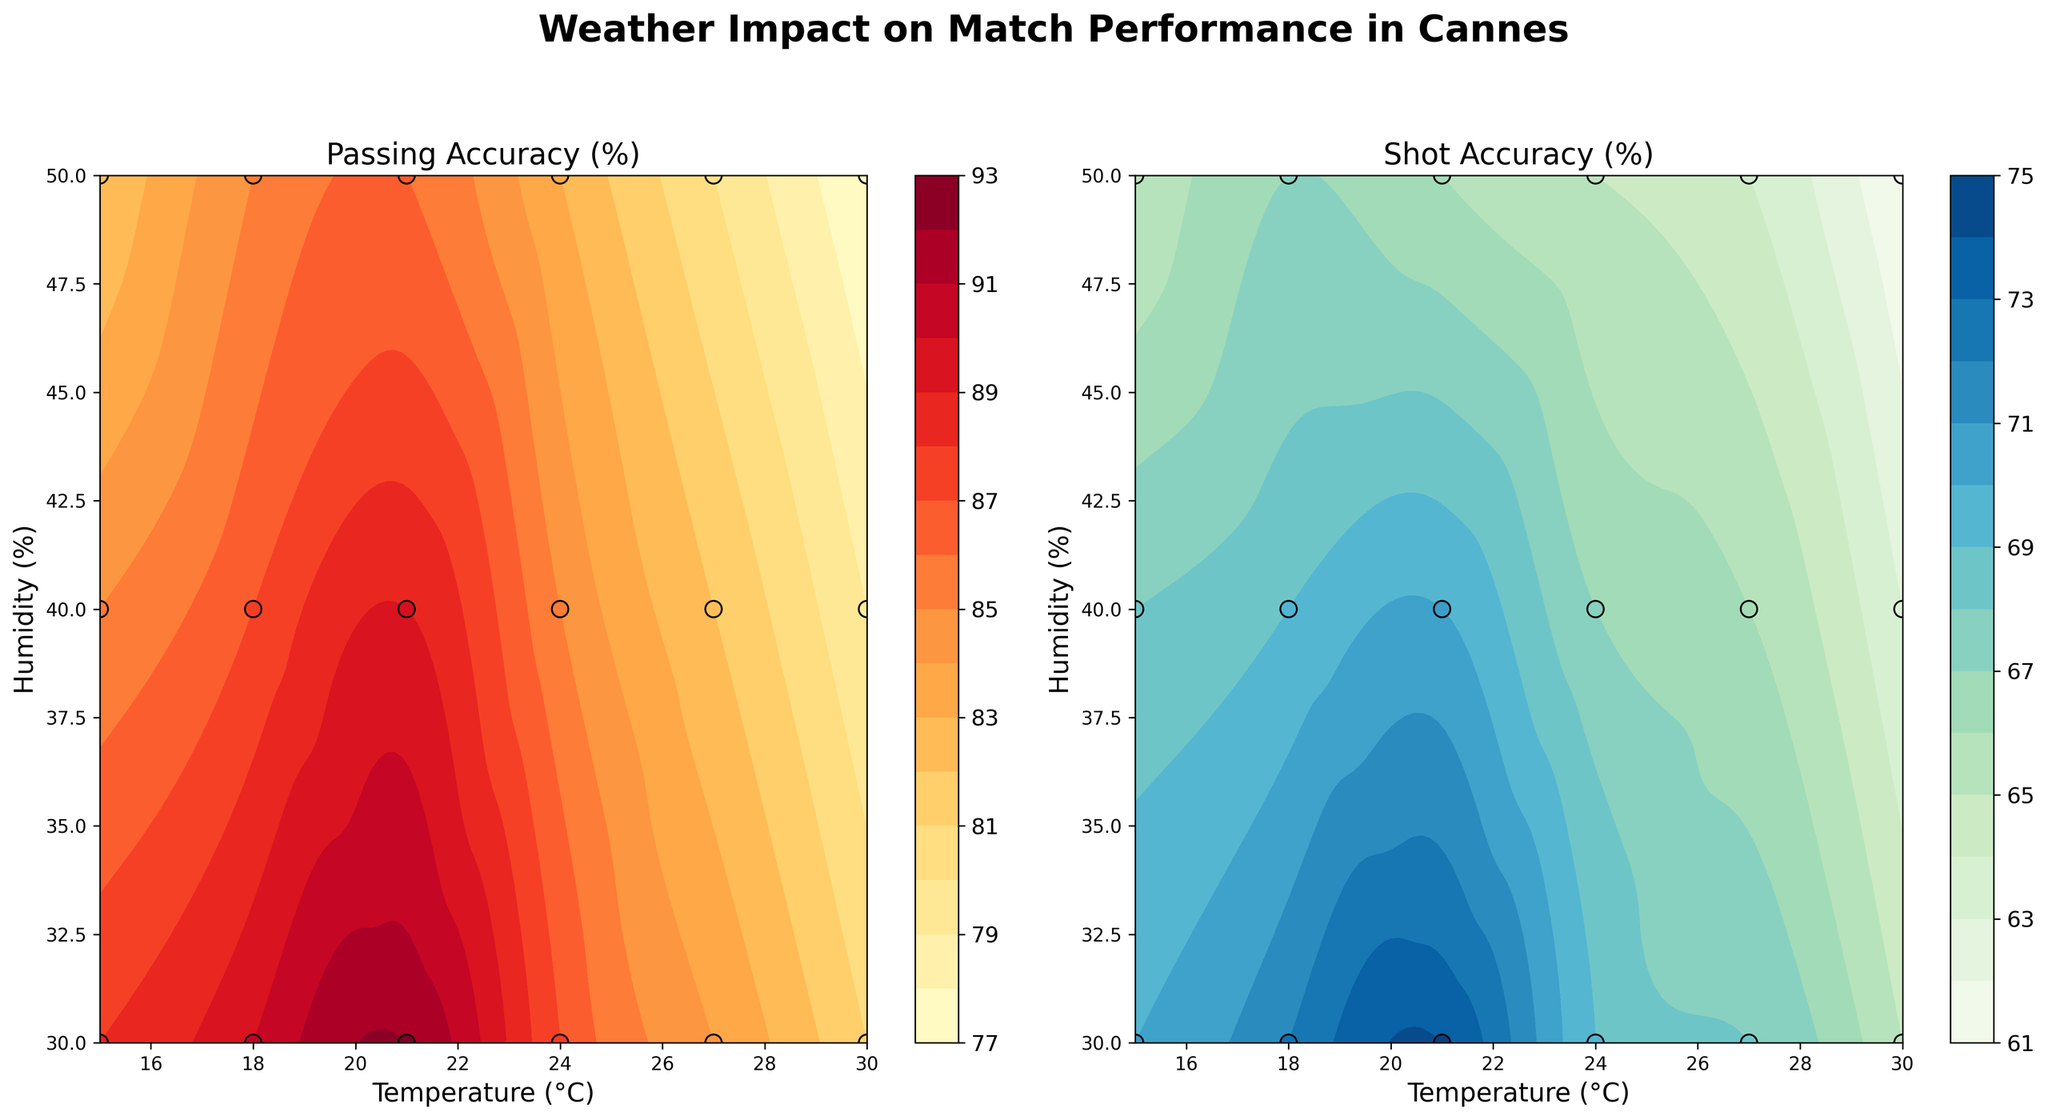What is the title of the figure? The title of the figure is written on the top center of the plot. It reads "Weather Impact on Match Performance in Cannes".
Answer: Weather Impact on Match Performance in Cannes How many subplots are there and what are their titles? There are two subplots. The titles are written above each subplot. The first subplot is titled "Passing Accuracy (%)" and the second subplot is titled "Shot Accuracy (%)".
Answer: Two; "Passing Accuracy (%)" and "Shot Accuracy (%)" Which temperature and humidity level shows the highest passing accuracy? Look at the contour plot for Passing Accuracy (%). Find the highest value and check the corresponding temperature and humidity levels. The highest passing accuracy is around 92%, which occurs at a temperature of 21°C and humidity of 30%.
Answer: 21°C and 30% At which temperature and humidity combination does the minimum shot accuracy occur? Examine the contour plot for Shot Accuracy (%). Identify the lowest value and note the corresponding temperature and humidity. The minimum shot accuracy is around 61%, occurring at a temperature of 30°C and humidity of 50%.
Answer: 30°C and 50% On average, how does shot accuracy vary with temperature regardless of humidity? Calculate the average shot accuracy for each temperature by considering all the humidity levels within each temperature group. Compare the averages across different temperatures. The shot accuracy tends to decrease as the temperature increases.
Answer: Decreases as temperature increases Is there a temperature and humidity combination where both passing and shot accuracy are above 85%? Check both plots for passing and shot accuracy percentages exceeding 85%. Identify if there is a common combination that meets this criterion. Both accuracy percentages are above 85% at 21°C and 30% humidity.
Answer: Yes, 21°C and 30% Compare the passing accuracy and shot accuracy at 24°C and 50% humidity. Which one is higher? Locate the data point at 24°C and 50% humidity in both subplots. Note the passing accuracy and shot accuracy values and compare them. Passing accuracy is 83%, and shot accuracy is 65%. Passing accuracy is higher.
Answer: Passing accuracy How do the contours in the passing accuracy plot change as humidity increases from 30% to 50%? Observe the passing accuracy contours across the humidity levels from 30% to 50%, holding temperature as a secondary factor. The contours indicate a general decrease in passing accuracy as humidity increases from 30% to 50%.
Answer: Decreases Do higher temperatures above 24°C generally lead to better or worse shot accuracy? Examine the sections of the shot accuracy plot corresponding to temperatures above 24°C. Generally, the contours suggest worse shot accuracy at higher temperatures above 24°C.
Answer: Worse Is the variability in passing accuracy more noticeable with changes in temperature or humidity? Compare the contour lines' density and gradient concerning changes in temperature and changes in humidity in the passing accuracy plot. More noticeable variability due to changes in temperature.
Answer: Temperature 